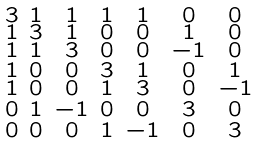<formula> <loc_0><loc_0><loc_500><loc_500>\begin{smallmatrix} 3 & 1 & 1 & 1 & 1 & 0 & 0 \\ 1 & 3 & 1 & 0 & 0 & 1 & 0 \\ 1 & 1 & 3 & 0 & 0 & - 1 & 0 \\ 1 & 0 & 0 & 3 & 1 & 0 & 1 \\ 1 & 0 & 0 & 1 & 3 & 0 & - 1 \\ 0 & 1 & - 1 & 0 & 0 & 3 & 0 \\ 0 & 0 & 0 & 1 & - 1 & 0 & 3 \end{smallmatrix}</formula> 